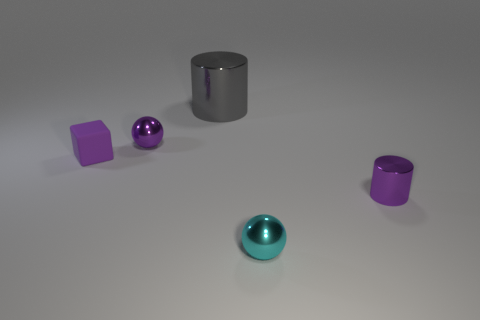The rubber thing that is the same color as the tiny cylinder is what shape?
Make the answer very short. Cube. How many other things are there of the same material as the purple block?
Make the answer very short. 0. Is there anything else that has the same size as the cyan shiny sphere?
Your response must be concise. Yes. There is a small purple shiny object in front of the metallic ball behind the tiny rubber thing; what shape is it?
Your answer should be very brief. Cylinder. Does the purple object that is in front of the rubber thing have the same material as the sphere to the left of the large gray shiny object?
Offer a very short reply. Yes. There is a metallic object to the left of the large gray shiny cylinder; how many big gray cylinders are behind it?
Give a very brief answer. 1. There is a cyan shiny object in front of the tiny purple cylinder; is its shape the same as the tiny purple object that is behind the purple matte block?
Provide a short and direct response. Yes. What size is the thing that is in front of the purple matte cube and behind the cyan metallic ball?
Make the answer very short. Small. The other thing that is the same shape as the gray object is what color?
Provide a succinct answer. Purple. What is the color of the metal sphere behind the tiny thing left of the tiny purple ball?
Give a very brief answer. Purple. 